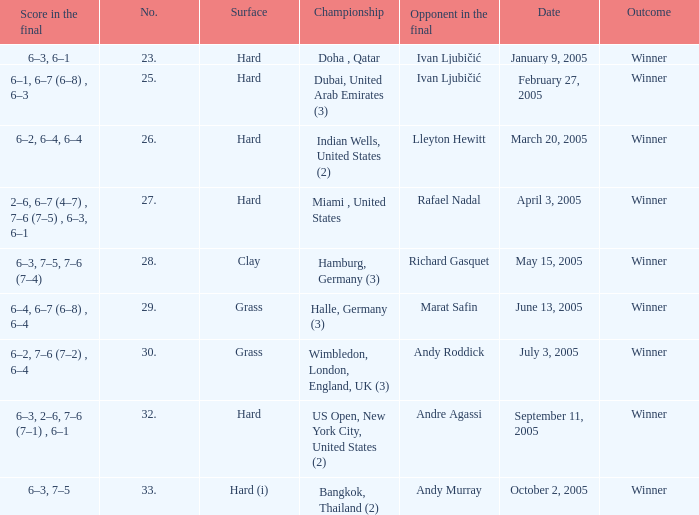Marat Safin is the opponent in the final in what championship? Halle, Germany (3). 